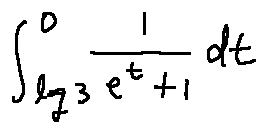<formula> <loc_0><loc_0><loc_500><loc_500>\int \lim i t s _ { \log 3 } ^ { 0 } \frac { 1 } { e ^ { t } + 1 } d t</formula> 